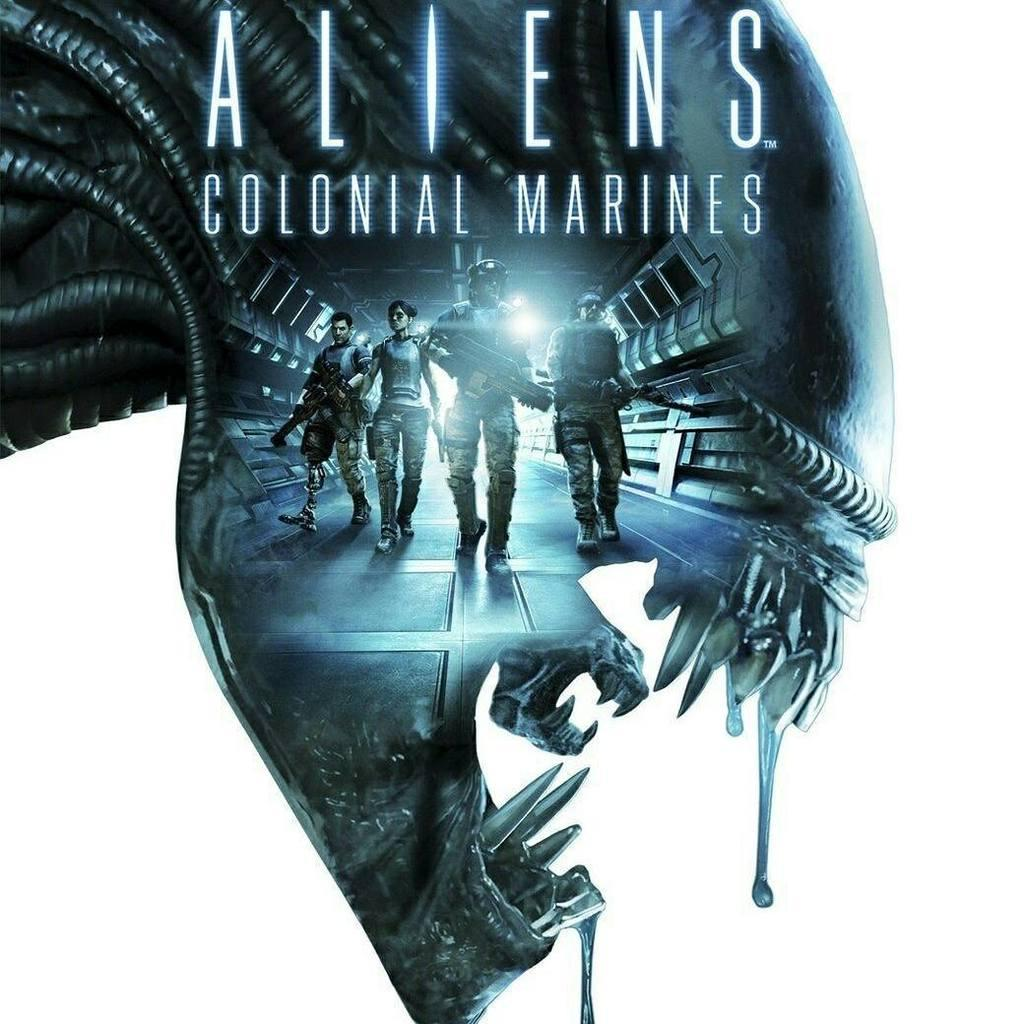<image>
Offer a succinct explanation of the picture presented. An advertisement for the game Aliens Colonial Marines. 